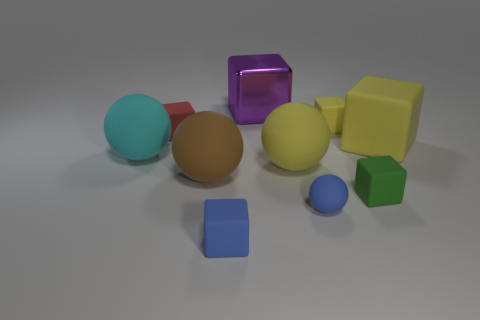What material is the big block that is on the right side of the purple metallic thing?
Your answer should be compact. Rubber. Is there any other thing that is the same size as the blue rubber sphere?
Make the answer very short. Yes. Is the number of blue matte cylinders less than the number of small rubber things?
Your answer should be compact. Yes. There is a rubber thing that is both right of the purple cube and to the left of the tiny sphere; what shape is it?
Keep it short and to the point. Sphere. What number of large rubber cubes are there?
Your answer should be compact. 1. What is the big cube in front of the yellow block that is behind the big block that is in front of the big purple metal object made of?
Offer a very short reply. Rubber. There is a small blue thing that is in front of the tiny blue matte sphere; how many large cyan objects are in front of it?
Ensure brevity in your answer.  0. What is the color of the other big matte object that is the same shape as the purple object?
Offer a very short reply. Yellow. Is the material of the small green object the same as the tiny red object?
Give a very brief answer. Yes. How many cubes are big gray shiny things or tiny red things?
Ensure brevity in your answer.  1. 